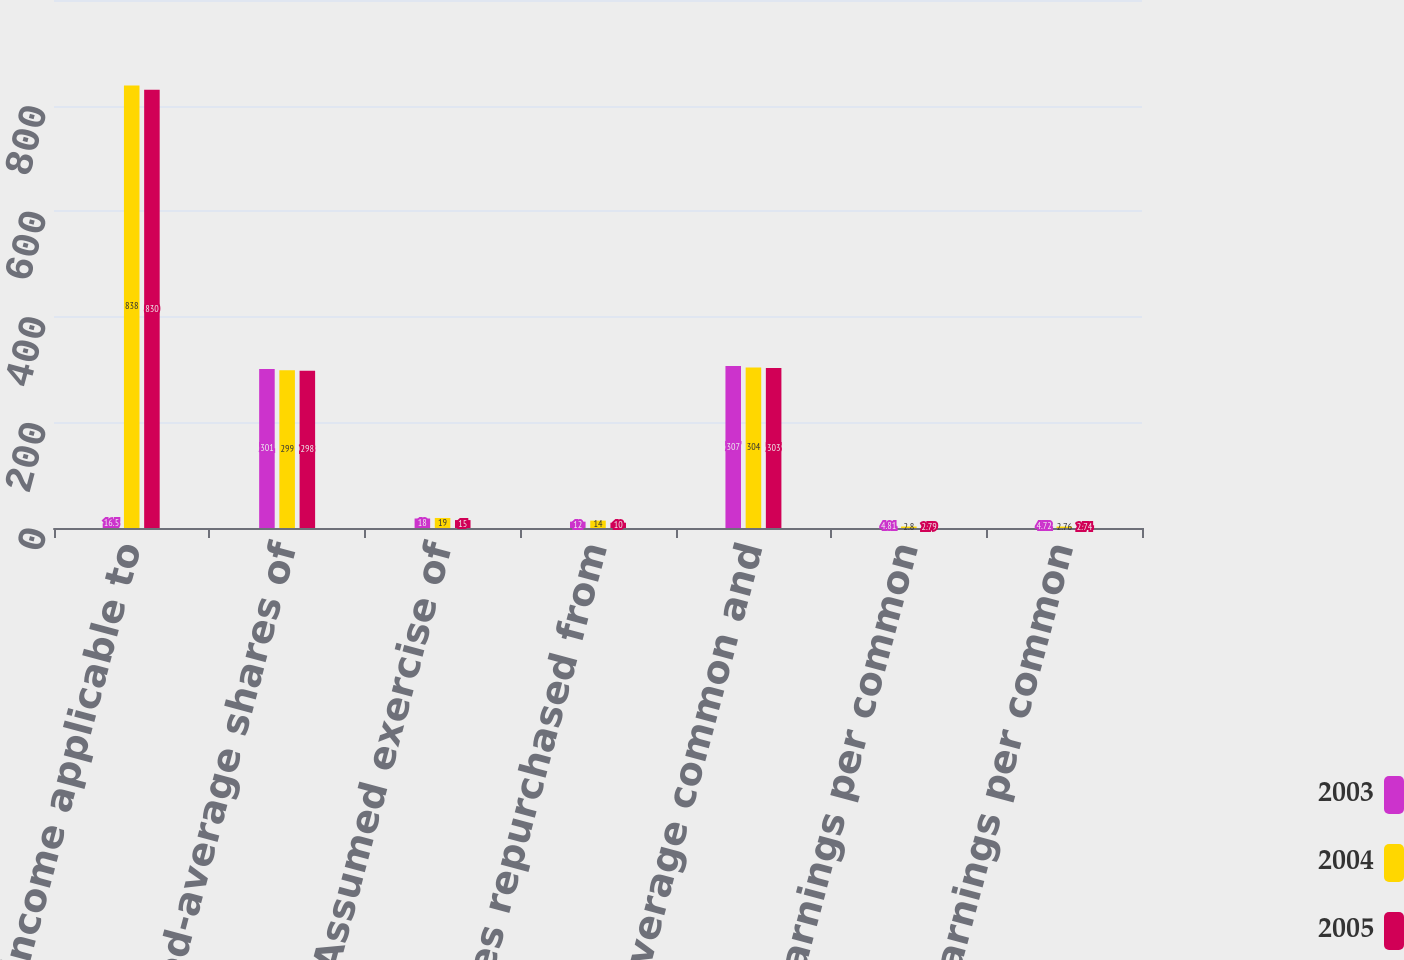Convert chart. <chart><loc_0><loc_0><loc_500><loc_500><stacked_bar_chart><ecel><fcel>Net income applicable to<fcel>Weighted-average shares of<fcel>Assumed exercise of<fcel>Less shares repurchased from<fcel>Weighted-average common and<fcel>Basic earnings per common<fcel>Diluted earnings per common<nl><fcel>2003<fcel>16.5<fcel>301<fcel>18<fcel>12<fcel>307<fcel>4.81<fcel>4.72<nl><fcel>2004<fcel>838<fcel>299<fcel>19<fcel>14<fcel>304<fcel>2.8<fcel>2.76<nl><fcel>2005<fcel>830<fcel>298<fcel>15<fcel>10<fcel>303<fcel>2.79<fcel>2.74<nl></chart> 